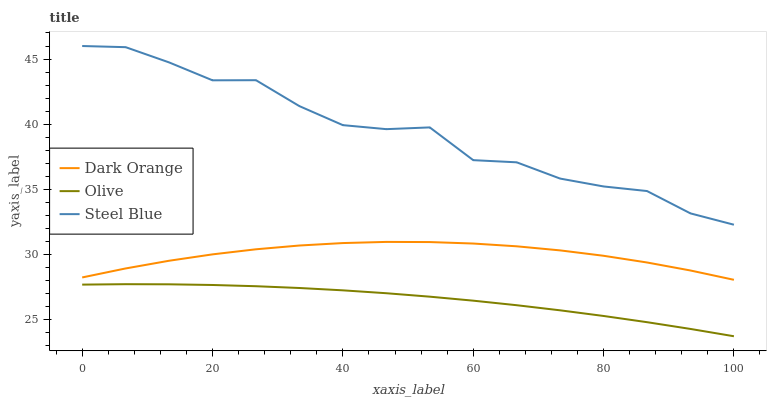Does Olive have the minimum area under the curve?
Answer yes or no. Yes. Does Steel Blue have the maximum area under the curve?
Answer yes or no. Yes. Does Dark Orange have the minimum area under the curve?
Answer yes or no. No. Does Dark Orange have the maximum area under the curve?
Answer yes or no. No. Is Olive the smoothest?
Answer yes or no. Yes. Is Steel Blue the roughest?
Answer yes or no. Yes. Is Dark Orange the smoothest?
Answer yes or no. No. Is Dark Orange the roughest?
Answer yes or no. No. Does Olive have the lowest value?
Answer yes or no. Yes. Does Dark Orange have the lowest value?
Answer yes or no. No. Does Steel Blue have the highest value?
Answer yes or no. Yes. Does Dark Orange have the highest value?
Answer yes or no. No. Is Dark Orange less than Steel Blue?
Answer yes or no. Yes. Is Dark Orange greater than Olive?
Answer yes or no. Yes. Does Dark Orange intersect Steel Blue?
Answer yes or no. No. 